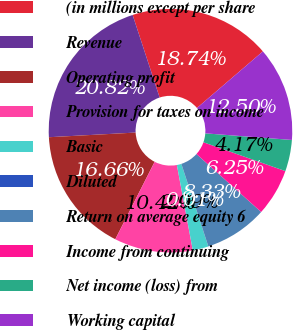Convert chart to OTSL. <chart><loc_0><loc_0><loc_500><loc_500><pie_chart><fcel>(in millions except per share<fcel>Revenue<fcel>Operating profit<fcel>Provision for taxes on income<fcel>Basic<fcel>Diluted<fcel>Return on average equity 6<fcel>Income from continuing<fcel>Net income (loss) from<fcel>Working capital<nl><fcel>18.74%<fcel>20.82%<fcel>16.66%<fcel>10.42%<fcel>2.09%<fcel>0.01%<fcel>8.33%<fcel>6.25%<fcel>4.17%<fcel>12.5%<nl></chart> 